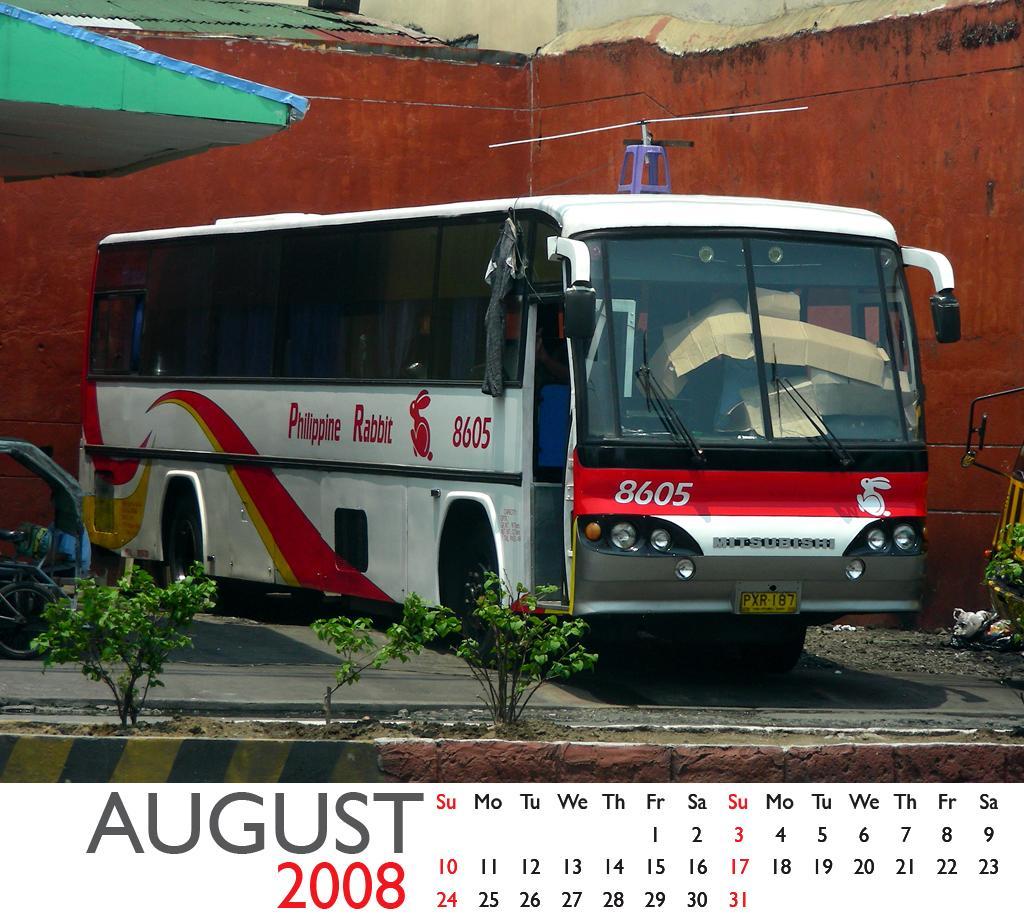Please provide a concise description of this image. In the foreground I can see the plants on the side of the road. In the background, I can see a bus on the road. I can see a vehicle on the left side. I can see the dates, month and year at the bottom of the picture. 